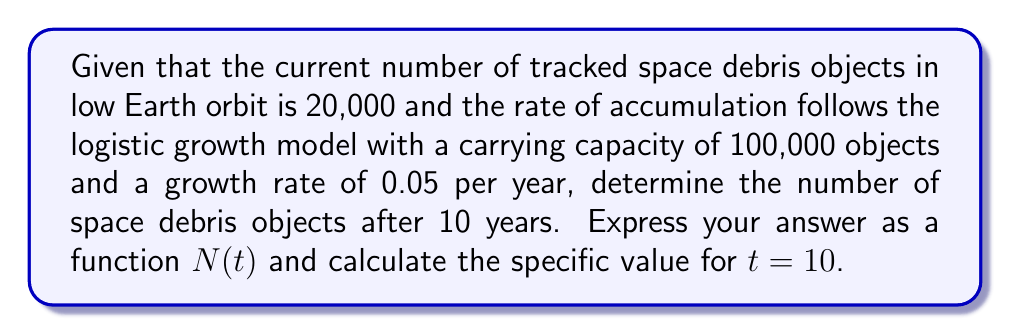Teach me how to tackle this problem. To solve this problem, we'll use the logistic growth model, which is appropriate for modeling populations with limited resources or capacity. The logistic growth equation is:

$$\frac{dN}{dt} = rN(1-\frac{N}{K})$$

Where:
- $N$ is the number of space debris objects
- $t$ is time in years
- $r$ is the growth rate (0.05 per year)
- $K$ is the carrying capacity (100,000 objects)

To find $N(t)$, we integrate this differential equation:

$$\int \frac{dN}{N(1-\frac{N}{K})} = \int r dt$$

The solution to this equation is:

$$N(t) = \frac{K}{1 + (\frac{K}{N_0} - 1)e^{-rt}}$$

Where $N_0$ is the initial number of space debris objects (20,000).

Substituting the given values:

$$N(t) = \frac{100000}{1 + (\frac{100000}{20000} - 1)e^{-0.05t}}$$

Simplifying:

$$N(t) = \frac{100000}{1 + 4e^{-0.05t}}$$

To find the number of space debris objects after 10 years, we calculate $N(10)$:

$$N(10) = \frac{100000}{1 + 4e^{-0.05(10)}} = \frac{100000}{1 + 4e^{-0.5}} \approx 28,047$$
Answer: $N(t) = \frac{100000}{1 + 4e^{-0.05t}}$; $N(10) \approx 28,047$ objects 